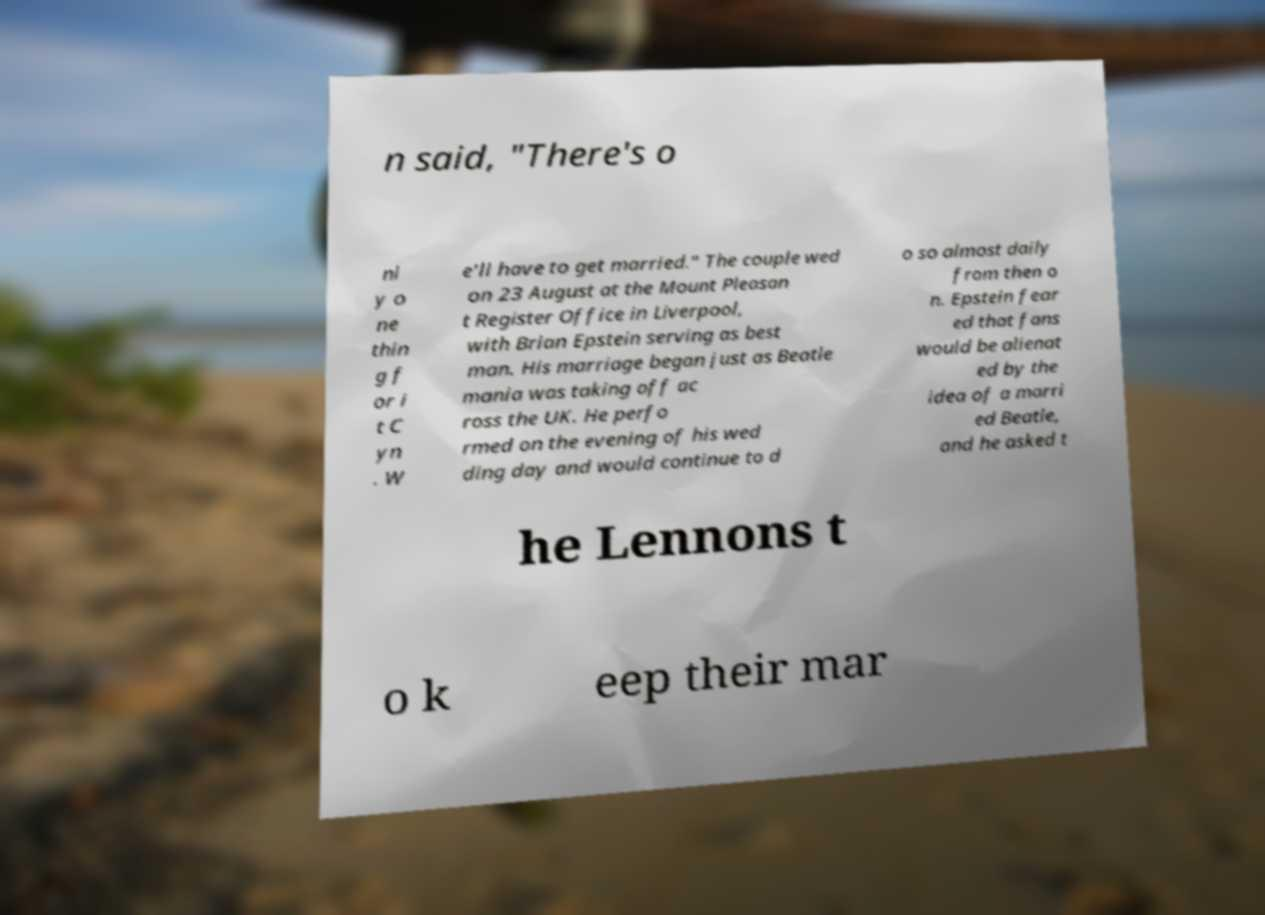What messages or text are displayed in this image? I need them in a readable, typed format. n said, "There's o nl y o ne thin g f or i t C yn . W e'll have to get married." The couple wed on 23 August at the Mount Pleasan t Register Office in Liverpool, with Brian Epstein serving as best man. His marriage began just as Beatle mania was taking off ac ross the UK. He perfo rmed on the evening of his wed ding day and would continue to d o so almost daily from then o n. Epstein fear ed that fans would be alienat ed by the idea of a marri ed Beatle, and he asked t he Lennons t o k eep their mar 